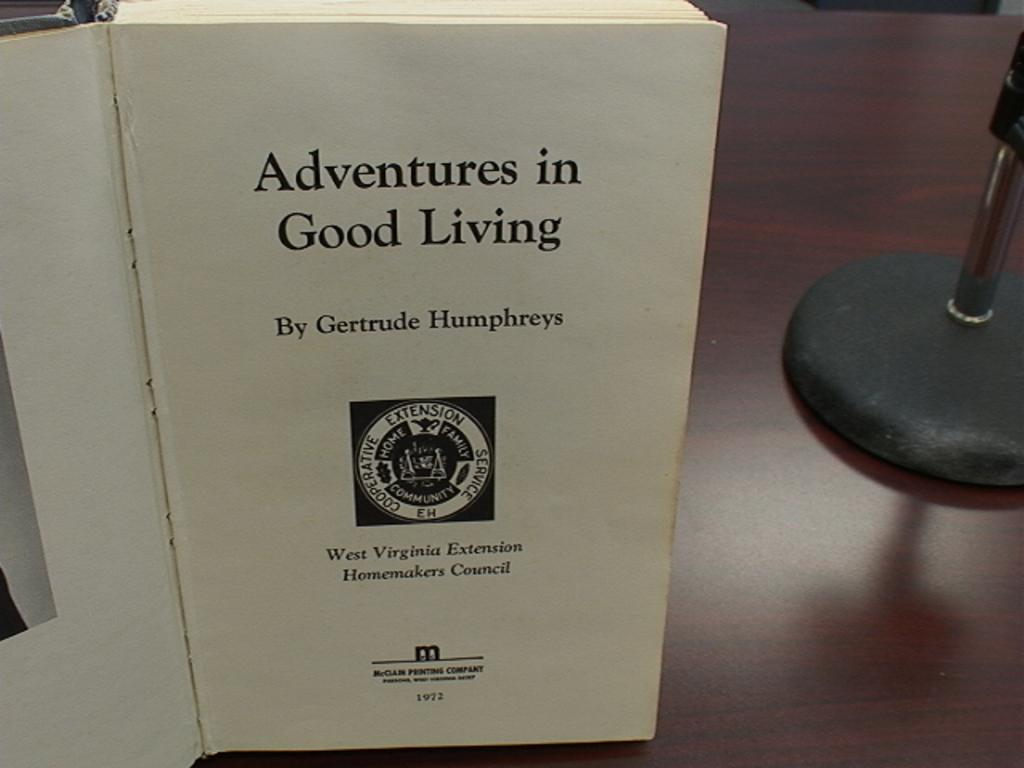<image>
Describe the image concisely. A book by Gertrude Humphreys open to the Title page,  sits upright on a table. 